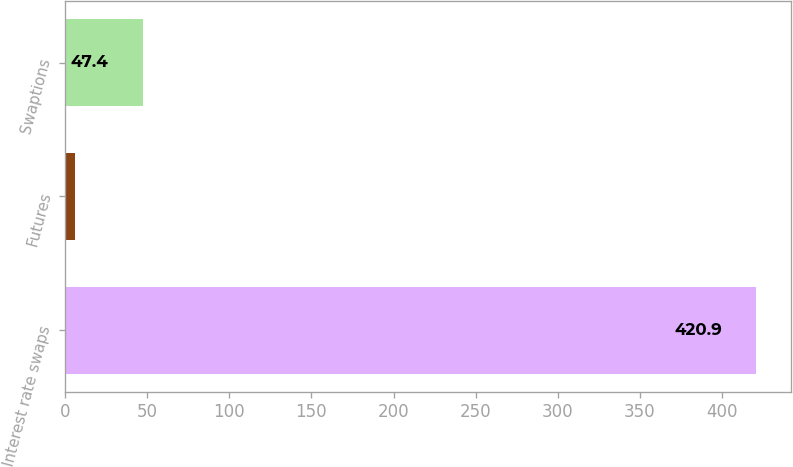<chart> <loc_0><loc_0><loc_500><loc_500><bar_chart><fcel>Interest rate swaps<fcel>Futures<fcel>Swaptions<nl><fcel>420.9<fcel>5.9<fcel>47.4<nl></chart> 